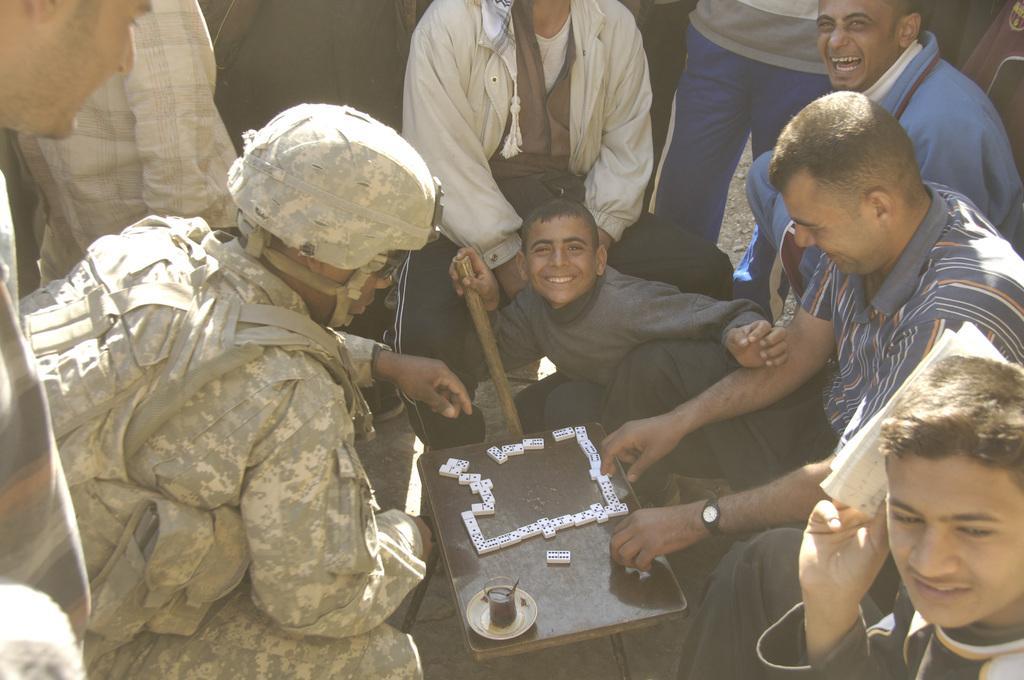Describe this image in one or two sentences. In this image we can see a table containing some blocks, a glass and a plate on it. We can also see a group of people around it. In that a man is holding a stick and the other is holding some papers. 